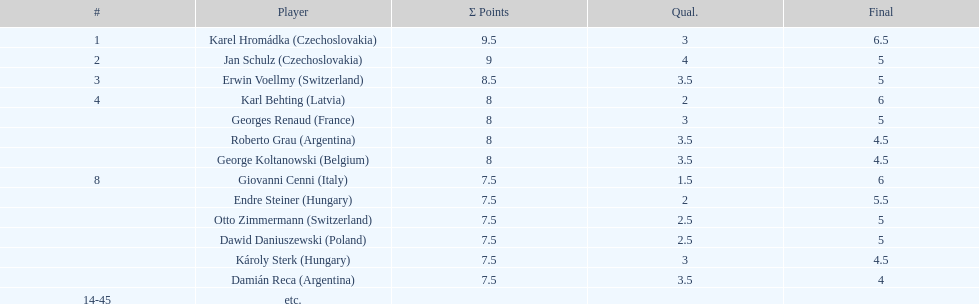How many players had a tie at the fourth place? 4. 